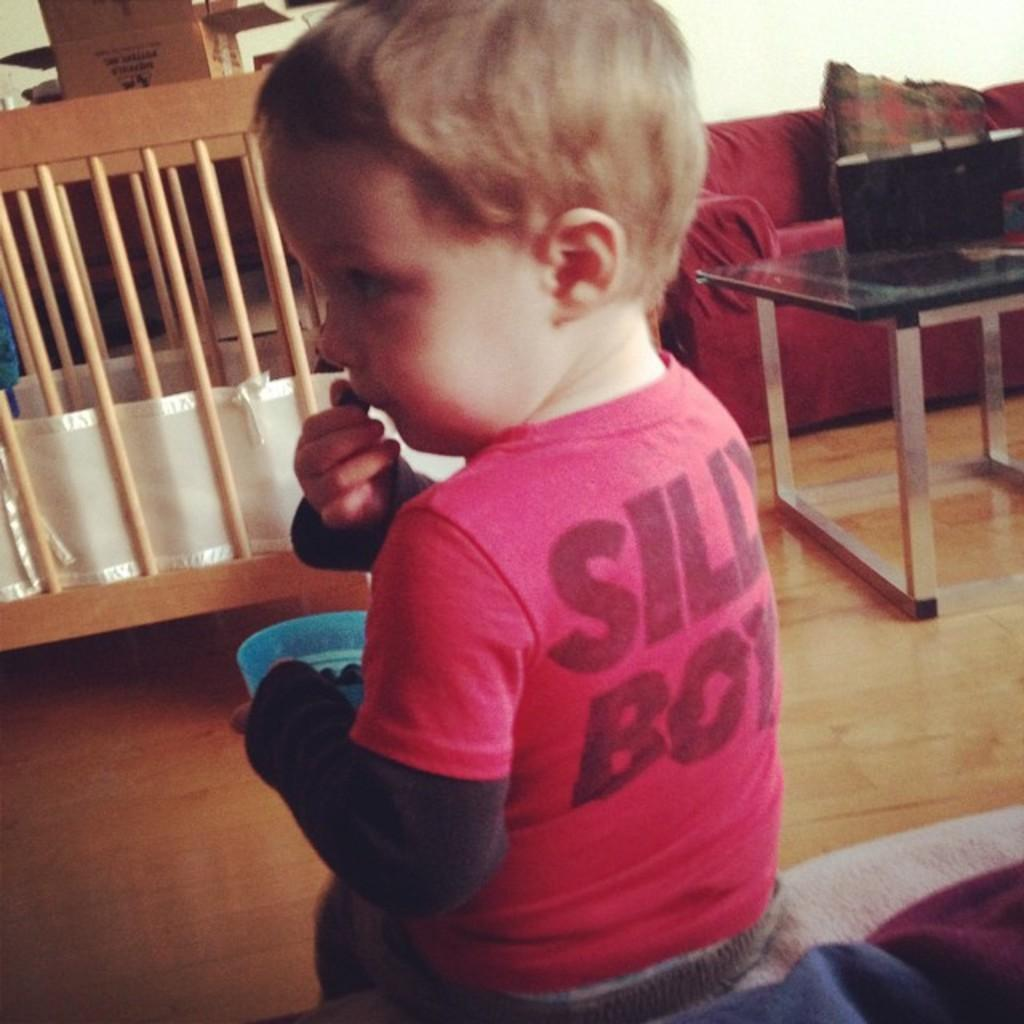What is the main subject of the image? The main subject of the image is a baby boy. What is the baby boy wearing? The baby boy is wearing a red t-shirt. What type of furniture can be seen on the right side of the image? There is a sofa set on the right side of the image. What other piece of furniture is present in the image? There is a table in the image. What type of offer is the carpenter making to the baby boy in the image? There is no carpenter or offer present in the image; it features a baby boy wearing a red t-shirt and some furniture. What type of sweater is the baby boy wearing in the image? The baby boy is not wearing a sweater in the image; he is wearing a red t-shirt. 